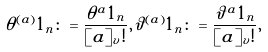Convert formula to latex. <formula><loc_0><loc_0><loc_500><loc_500>\theta ^ { ( a ) } 1 _ { n } \colon = \frac { \theta ^ { a } 1 _ { n } } { [ a ] _ { v } ! } , \vartheta ^ { ( a ) } 1 _ { n } \colon = \frac { \vartheta ^ { a } 1 _ { n } } { [ a ] _ { v } ! } ,</formula> 